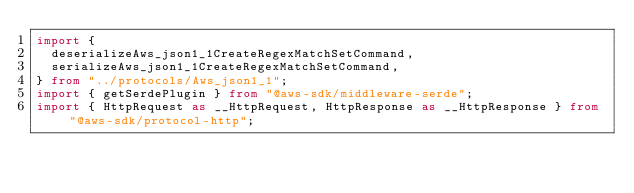Convert code to text. <code><loc_0><loc_0><loc_500><loc_500><_TypeScript_>import {
  deserializeAws_json1_1CreateRegexMatchSetCommand,
  serializeAws_json1_1CreateRegexMatchSetCommand,
} from "../protocols/Aws_json1_1";
import { getSerdePlugin } from "@aws-sdk/middleware-serde";
import { HttpRequest as __HttpRequest, HttpResponse as __HttpResponse } from "@aws-sdk/protocol-http";</code> 